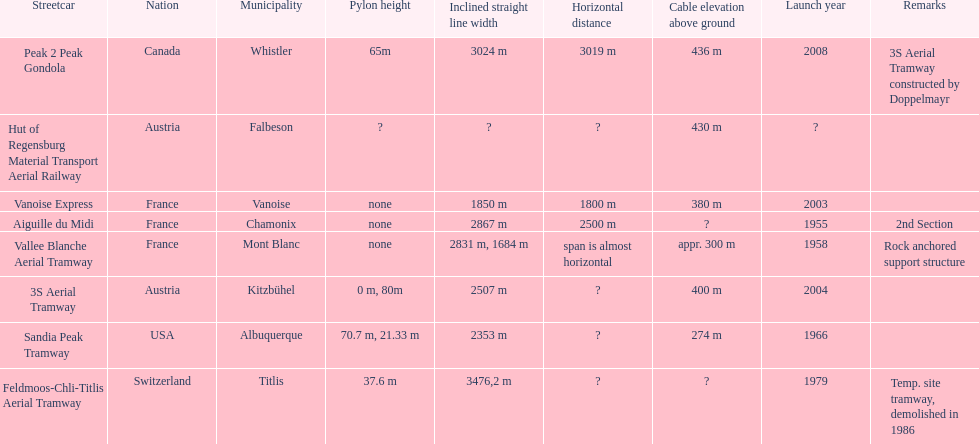After 1970, how many aerial tramways were inaugurated at the very least? 4. Parse the full table. {'header': ['Streetcar', 'Nation', 'Municipality', 'Pylon height', 'Inclined straight line width', 'Horizontal distance', 'Cable elevation above ground', 'Launch year', 'Remarks'], 'rows': [['Peak 2 Peak Gondola', 'Canada', 'Whistler', '65m', '3024 m', '3019 m', '436 m', '2008', '3S Aerial Tramway constructed by Doppelmayr'], ['Hut of Regensburg Material Transport Aerial Railway', 'Austria', 'Falbeson', '?', '?', '?', '430 m', '?', ''], ['Vanoise Express', 'France', 'Vanoise', 'none', '1850 m', '1800 m', '380 m', '2003', ''], ['Aiguille du Midi', 'France', 'Chamonix', 'none', '2867 m', '2500 m', '?', '1955', '2nd Section'], ['Vallee Blanche Aerial Tramway', 'France', 'Mont Blanc', 'none', '2831 m, 1684 m', 'span is almost horizontal', 'appr. 300 m', '1958', 'Rock anchored support structure'], ['3S Aerial Tramway', 'Austria', 'Kitzbühel', '0 m, 80m', '2507 m', '?', '400 m', '2004', ''], ['Sandia Peak Tramway', 'USA', 'Albuquerque', '70.7 m, 21.33 m', '2353 m', '?', '274 m', '1966', ''], ['Feldmoos-Chli-Titlis Aerial Tramway', 'Switzerland', 'Titlis', '37.6 m', '3476,2 m', '?', '?', '1979', 'Temp. site tramway, demolished in 1986']]} 